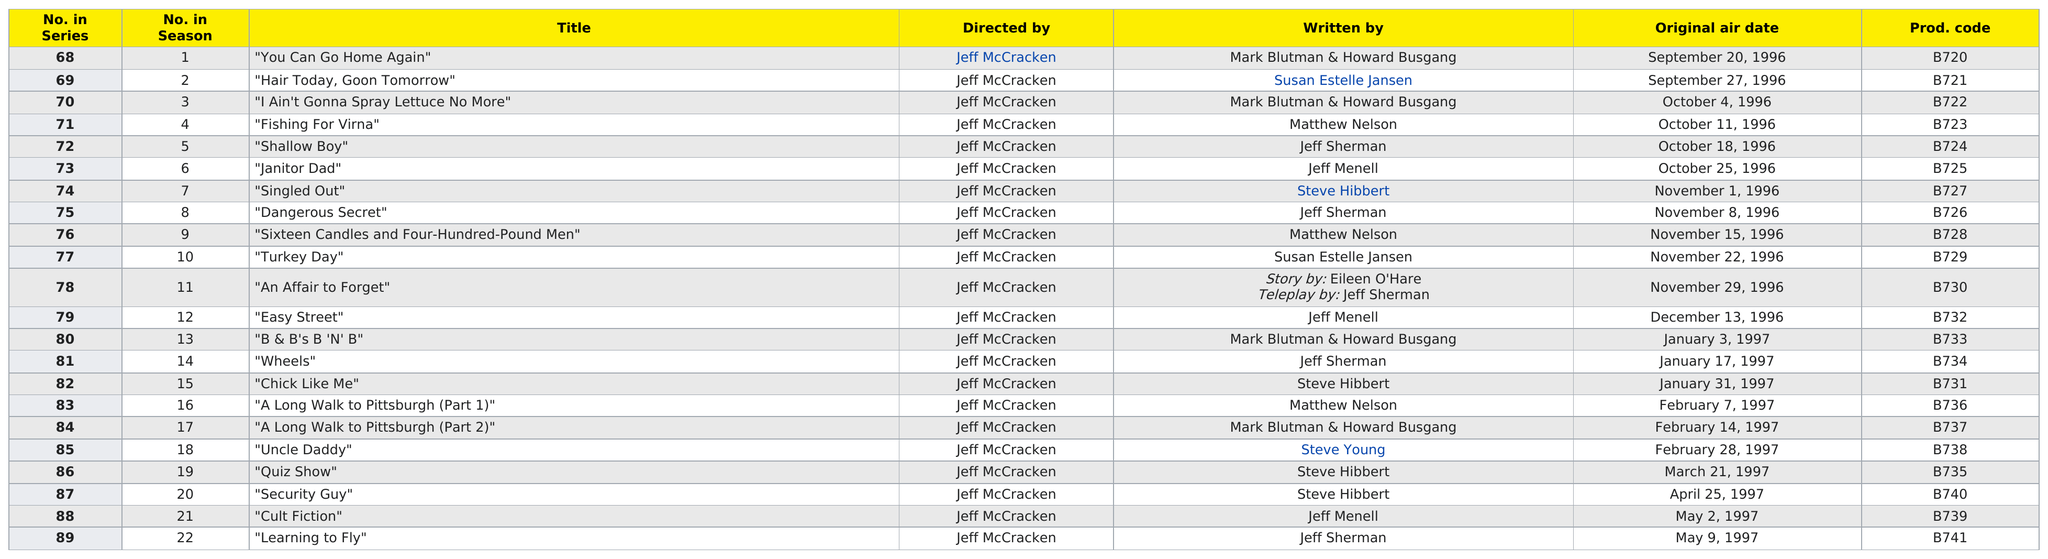List a handful of essential elements in this visual. In 1997, there were ten episodes. There are 22 episodes that were directed by Jeff McCracken. I am unable to perform that action as I am not able to access information about a specific date in May 1997 and the number of episodes that aired on that date. Additionally, it is not clear what context this information is being provided in or what it is being used for. What is the highest number in the series? 89. Mark Blutman and Howard Busgang wrote the first episode of the season. 